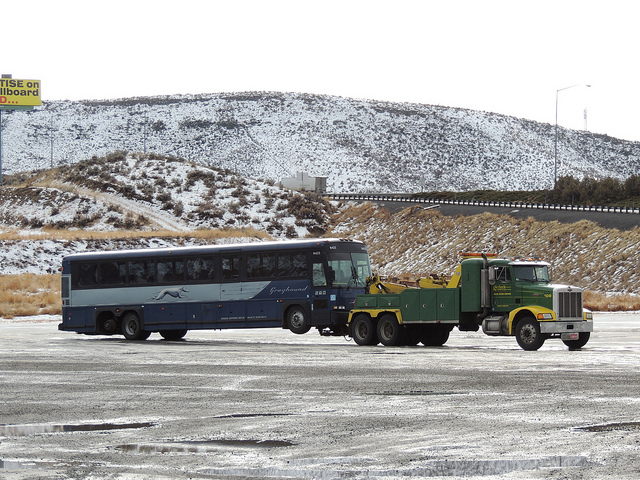<image>Is the bus occupied? I am not sure whether the bus is occupied or not. Is the bus occupied? I don't know if the bus is occupied. It can be either occupied or not. 